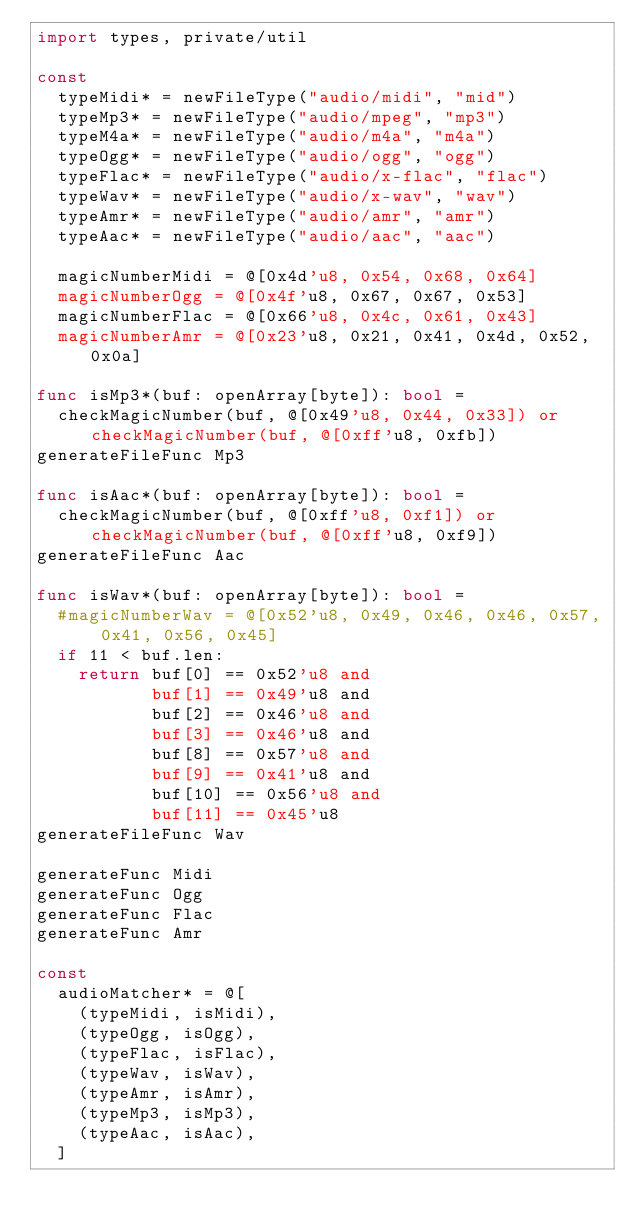<code> <loc_0><loc_0><loc_500><loc_500><_Nim_>import types, private/util

const
  typeMidi* = newFileType("audio/midi", "mid")
  typeMp3* = newFileType("audio/mpeg", "mp3")
  typeM4a* = newFileType("audio/m4a", "m4a")
  typeOgg* = newFileType("audio/ogg", "ogg")
  typeFlac* = newFileType("audio/x-flac", "flac")
  typeWav* = newFileType("audio/x-wav", "wav")
  typeAmr* = newFileType("audio/amr", "amr")
  typeAac* = newFileType("audio/aac", "aac")

  magicNumberMidi = @[0x4d'u8, 0x54, 0x68, 0x64]
  magicNumberOgg = @[0x4f'u8, 0x67, 0x67, 0x53]
  magicNumberFlac = @[0x66'u8, 0x4c, 0x61, 0x43]
  magicNumberAmr = @[0x23'u8, 0x21, 0x41, 0x4d, 0x52, 0x0a]

func isMp3*(buf: openArray[byte]): bool =
  checkMagicNumber(buf, @[0x49'u8, 0x44, 0x33]) or checkMagicNumber(buf, @[0xff'u8, 0xfb])
generateFileFunc Mp3

func isAac*(buf: openArray[byte]): bool =
  checkMagicNumber(buf, @[0xff'u8, 0xf1]) or checkMagicNumber(buf, @[0xff'u8, 0xf9])
generateFileFunc Aac

func isWav*(buf: openArray[byte]): bool =
  #magicNumberWav = @[0x52'u8, 0x49, 0x46, 0x46, 0x57, 0x41, 0x56, 0x45]
  if 11 < buf.len:
    return buf[0] == 0x52'u8 and
           buf[1] == 0x49'u8 and
           buf[2] == 0x46'u8 and
           buf[3] == 0x46'u8 and
           buf[8] == 0x57'u8 and
           buf[9] == 0x41'u8 and
           buf[10] == 0x56'u8 and
           buf[11] == 0x45'u8
generateFileFunc Wav

generateFunc Midi
generateFunc Ogg
generateFunc Flac
generateFunc Amr

const
  audioMatcher* = @[
    (typeMidi, isMidi),
    (typeOgg, isOgg),
    (typeFlac, isFlac),
    (typeWav, isWav),
    (typeAmr, isAmr),
    (typeMp3, isMp3),
    (typeAac, isAac),
  ]

</code> 